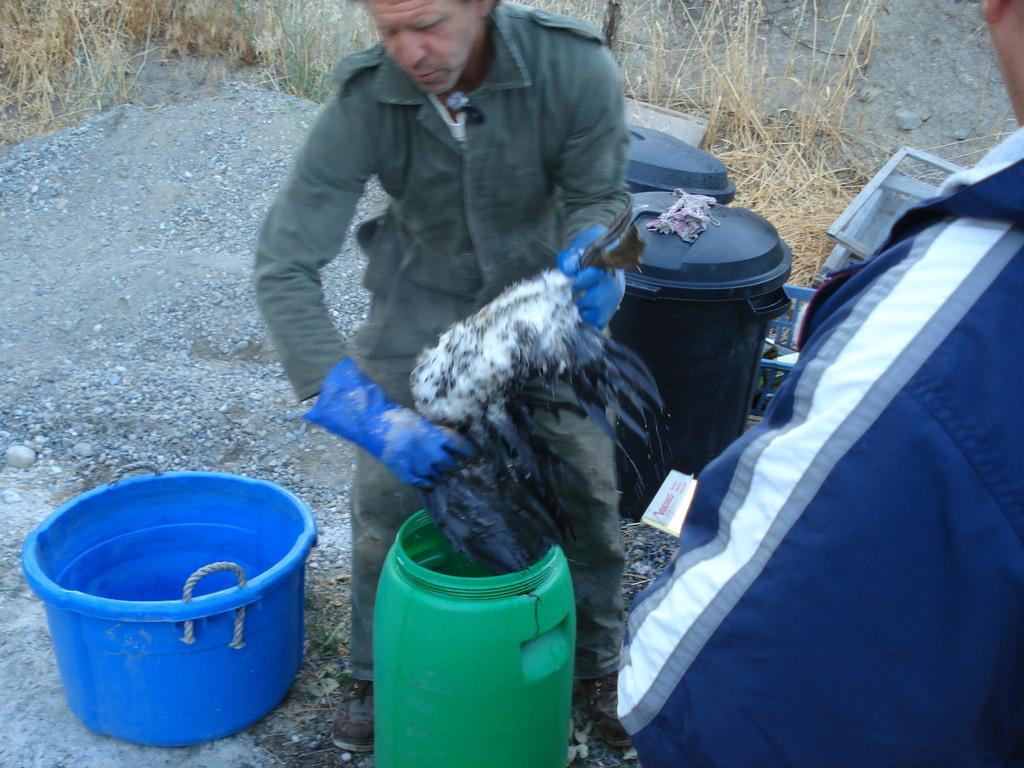How many people are in the image? There are two men in the image. What is one of the men holding in his hands? One of the men is holding something in his hands. What type of objects can be seen in the image? There are plastic objects in the image. Can you describe the drum in the image? There is a green color drum in the image. What can be seen in the background of the image? There is grass visible in the background of the image. What type of brush is being used to support the relation between the two men in the image? There is no brush or indication of a relation between the two men in the image. 